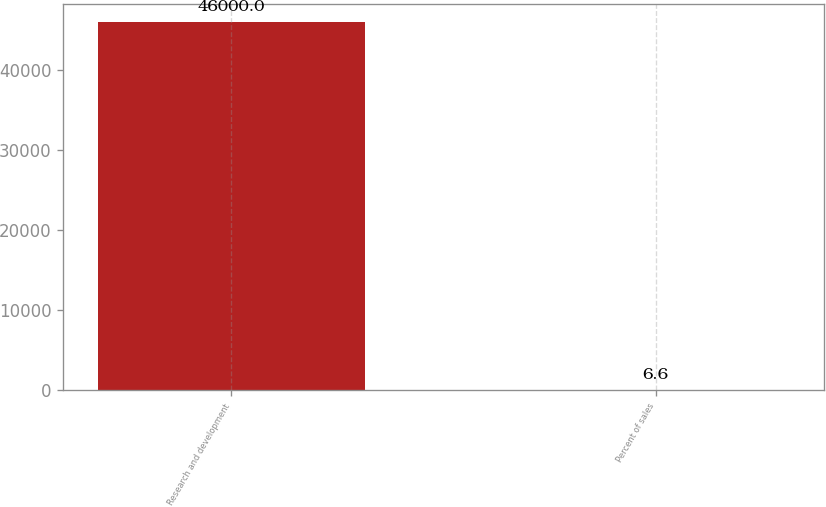<chart> <loc_0><loc_0><loc_500><loc_500><bar_chart><fcel>Research and development<fcel>Percent of sales<nl><fcel>46000<fcel>6.6<nl></chart> 